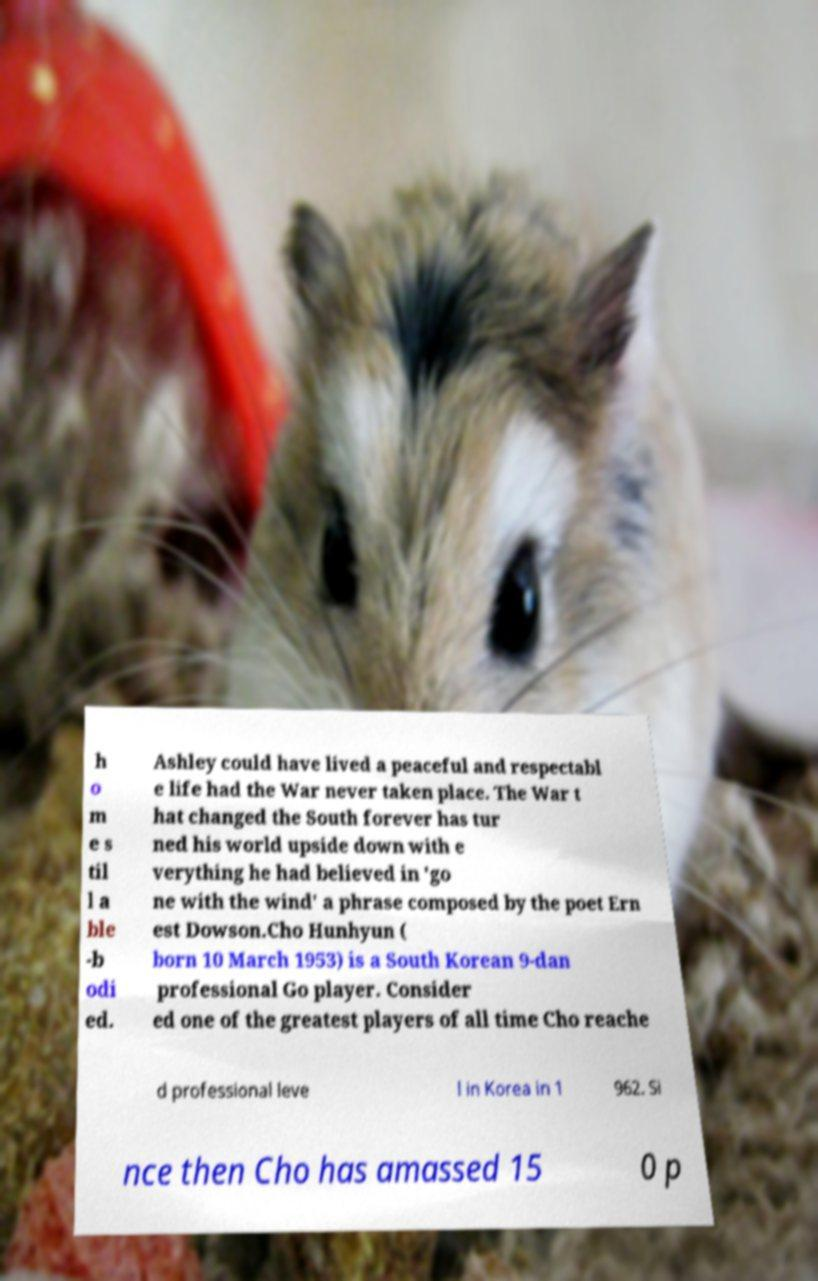Please identify and transcribe the text found in this image. h o m e s til l a ble -b odi ed. Ashley could have lived a peaceful and respectabl e life had the War never taken place. The War t hat changed the South forever has tur ned his world upside down with e verything he had believed in 'go ne with the wind' a phrase composed by the poet Ern est Dowson.Cho Hunhyun ( born 10 March 1953) is a South Korean 9-dan professional Go player. Consider ed one of the greatest players of all time Cho reache d professional leve l in Korea in 1 962. Si nce then Cho has amassed 15 0 p 